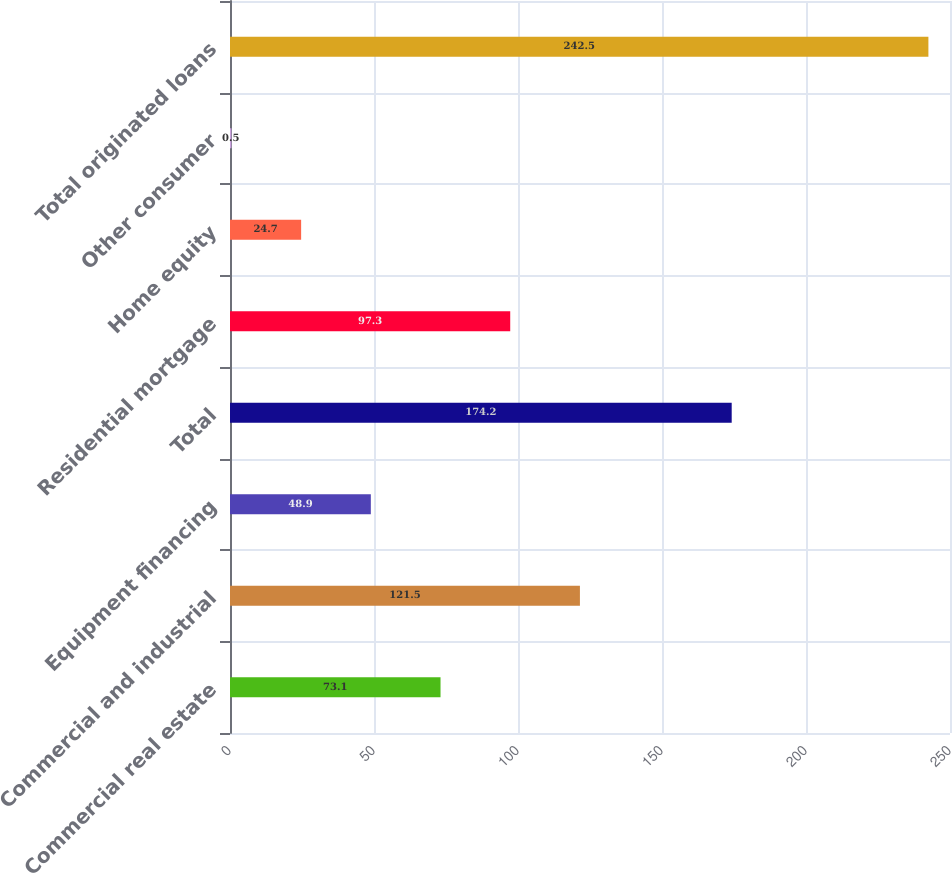<chart> <loc_0><loc_0><loc_500><loc_500><bar_chart><fcel>Commercial real estate<fcel>Commercial and industrial<fcel>Equipment financing<fcel>Total<fcel>Residential mortgage<fcel>Home equity<fcel>Other consumer<fcel>Total originated loans<nl><fcel>73.1<fcel>121.5<fcel>48.9<fcel>174.2<fcel>97.3<fcel>24.7<fcel>0.5<fcel>242.5<nl></chart> 